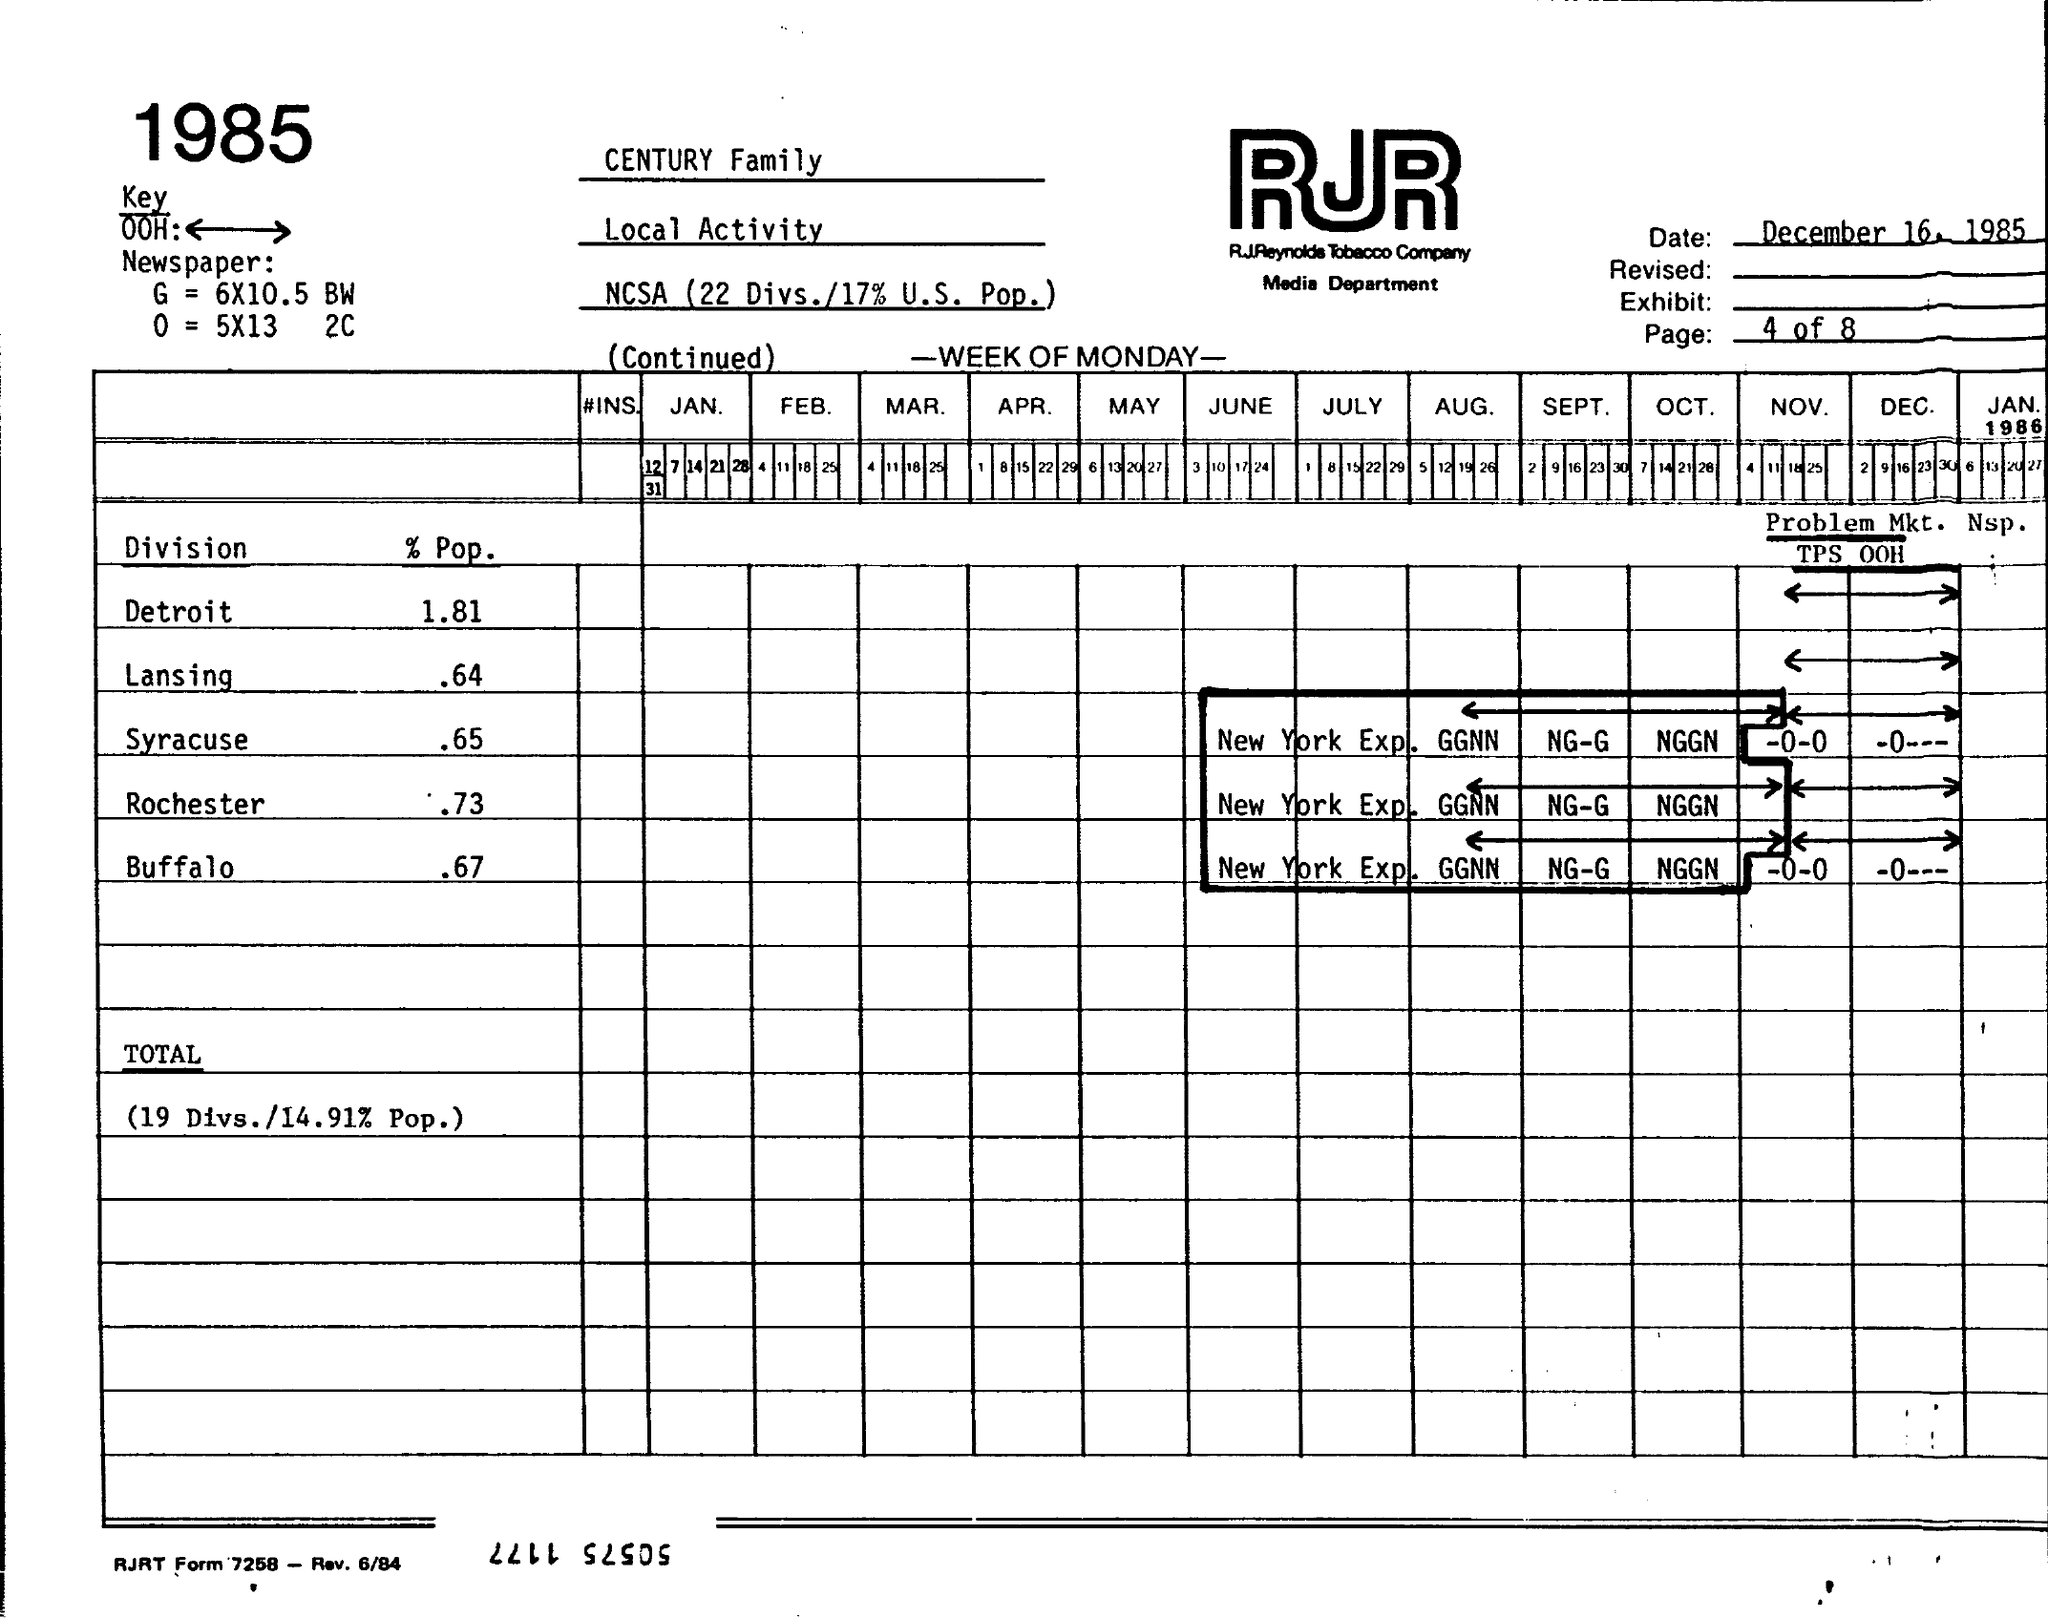What does 'NCSA 22 Divs./17% U.S. Pop.' mean? The notation 'NCSA 22 Divs./17% U.S. Pop.' likely refers to the distribution of a certain activity, probably advertising or sales, across 22 divisions of the company's operations, which collectively cover about 17% of the U.S. population. NCSA might be an abbreviation for a specific term relevant to the company's departments or sectors. 